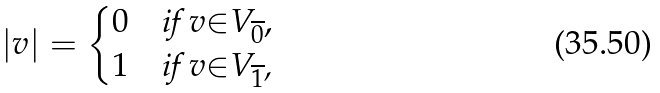<formula> <loc_0><loc_0><loc_500><loc_500>| v | = \begin{cases} 0 & \text {if $v{\in}V_{\overline{0}}$} , \\ 1 & \text {if $v{\in}V_{\overline{1}}$,} \end{cases}</formula> 